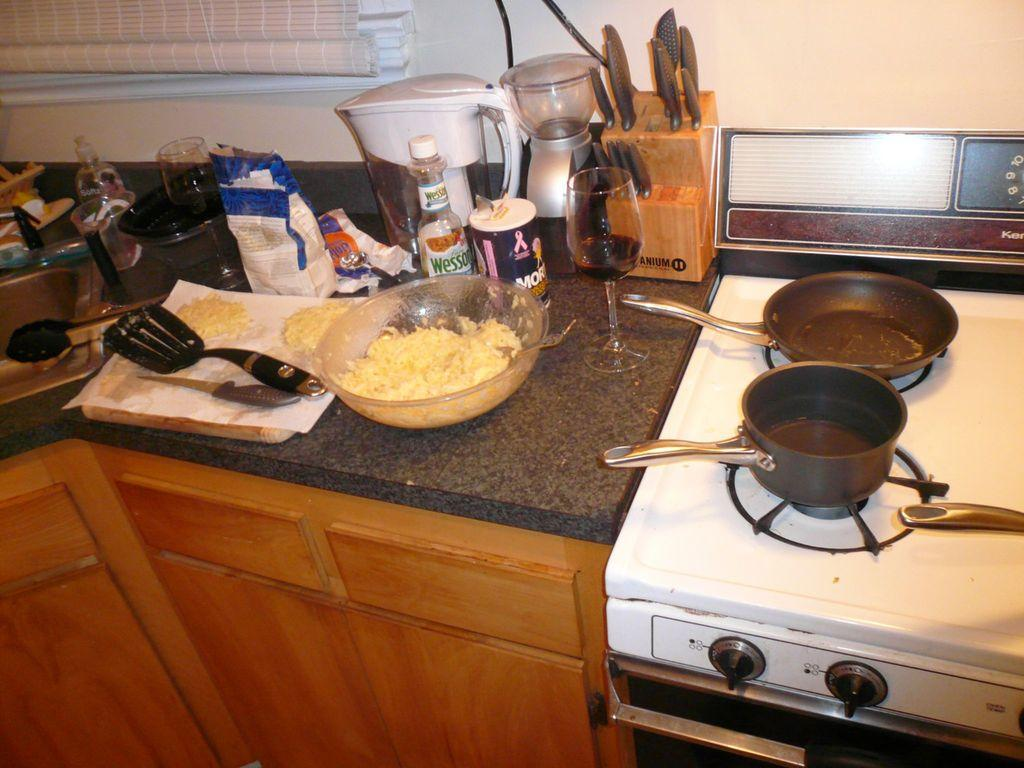What is present on the countertop in the image? In the image, there is a bowl, knives, glasses, bottles, machines, and other things on the countertop. What is the purpose of the knives in the image? The knives in the image are likely used for cutting or preparing food. What can be found on the gas stove in the image? There are bowls on the gas stove in the image. What else is present in the image besides the items on the countertop? There are machines in the image. What type of art can be seen hanging on the wall in the image? There is no art visible on the wall in the image. What type of pickle is being prepared in the bowls on the gas stove? There is no pickle present in the image; there are only bowls on the gas stove. 